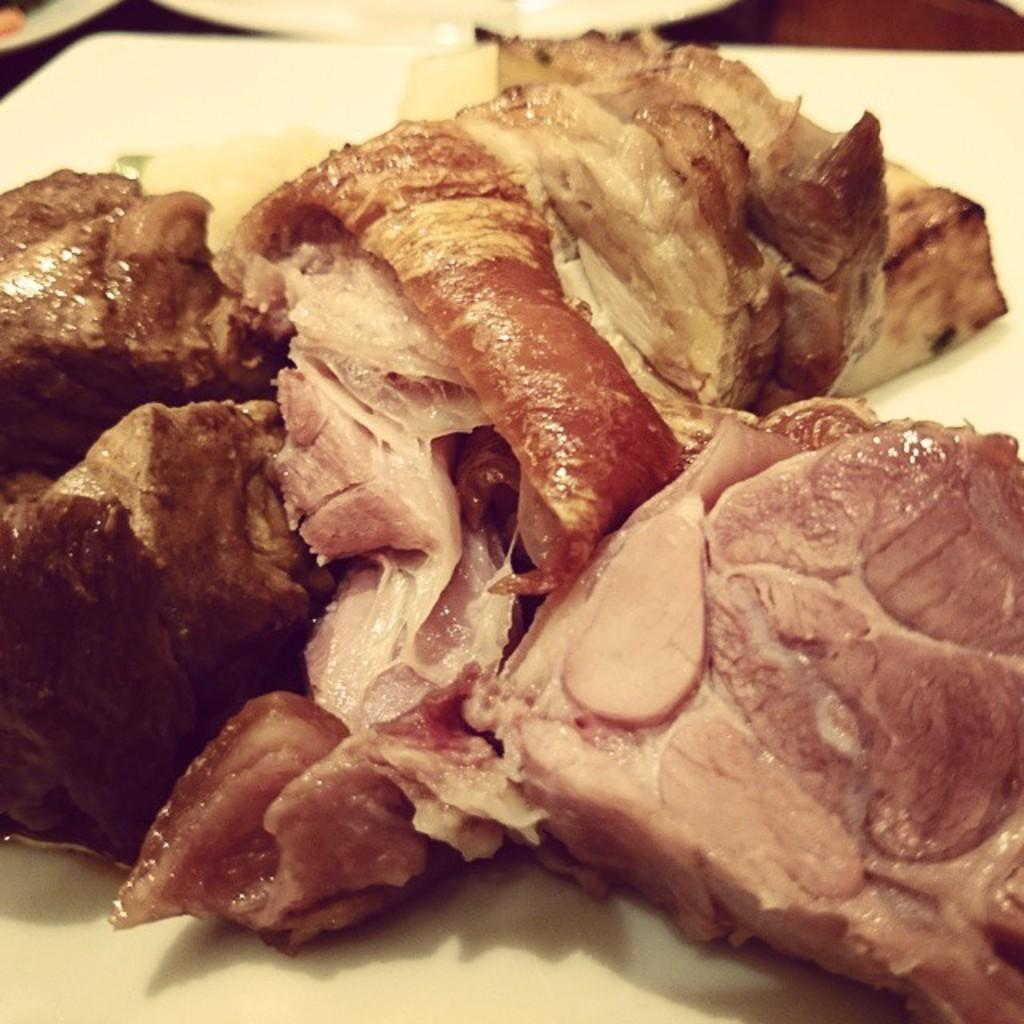Where was the image taken? The image is taken indoors. What type of food can be seen on one of the plates in the image? There is a plate with a food item made of meat in the image. How many plates are visible on the table in the image? There are two plates on a table in the image. What type of scent can be detected from the babies in the image? There are no babies present in the image, so no scent can be detected from them. 